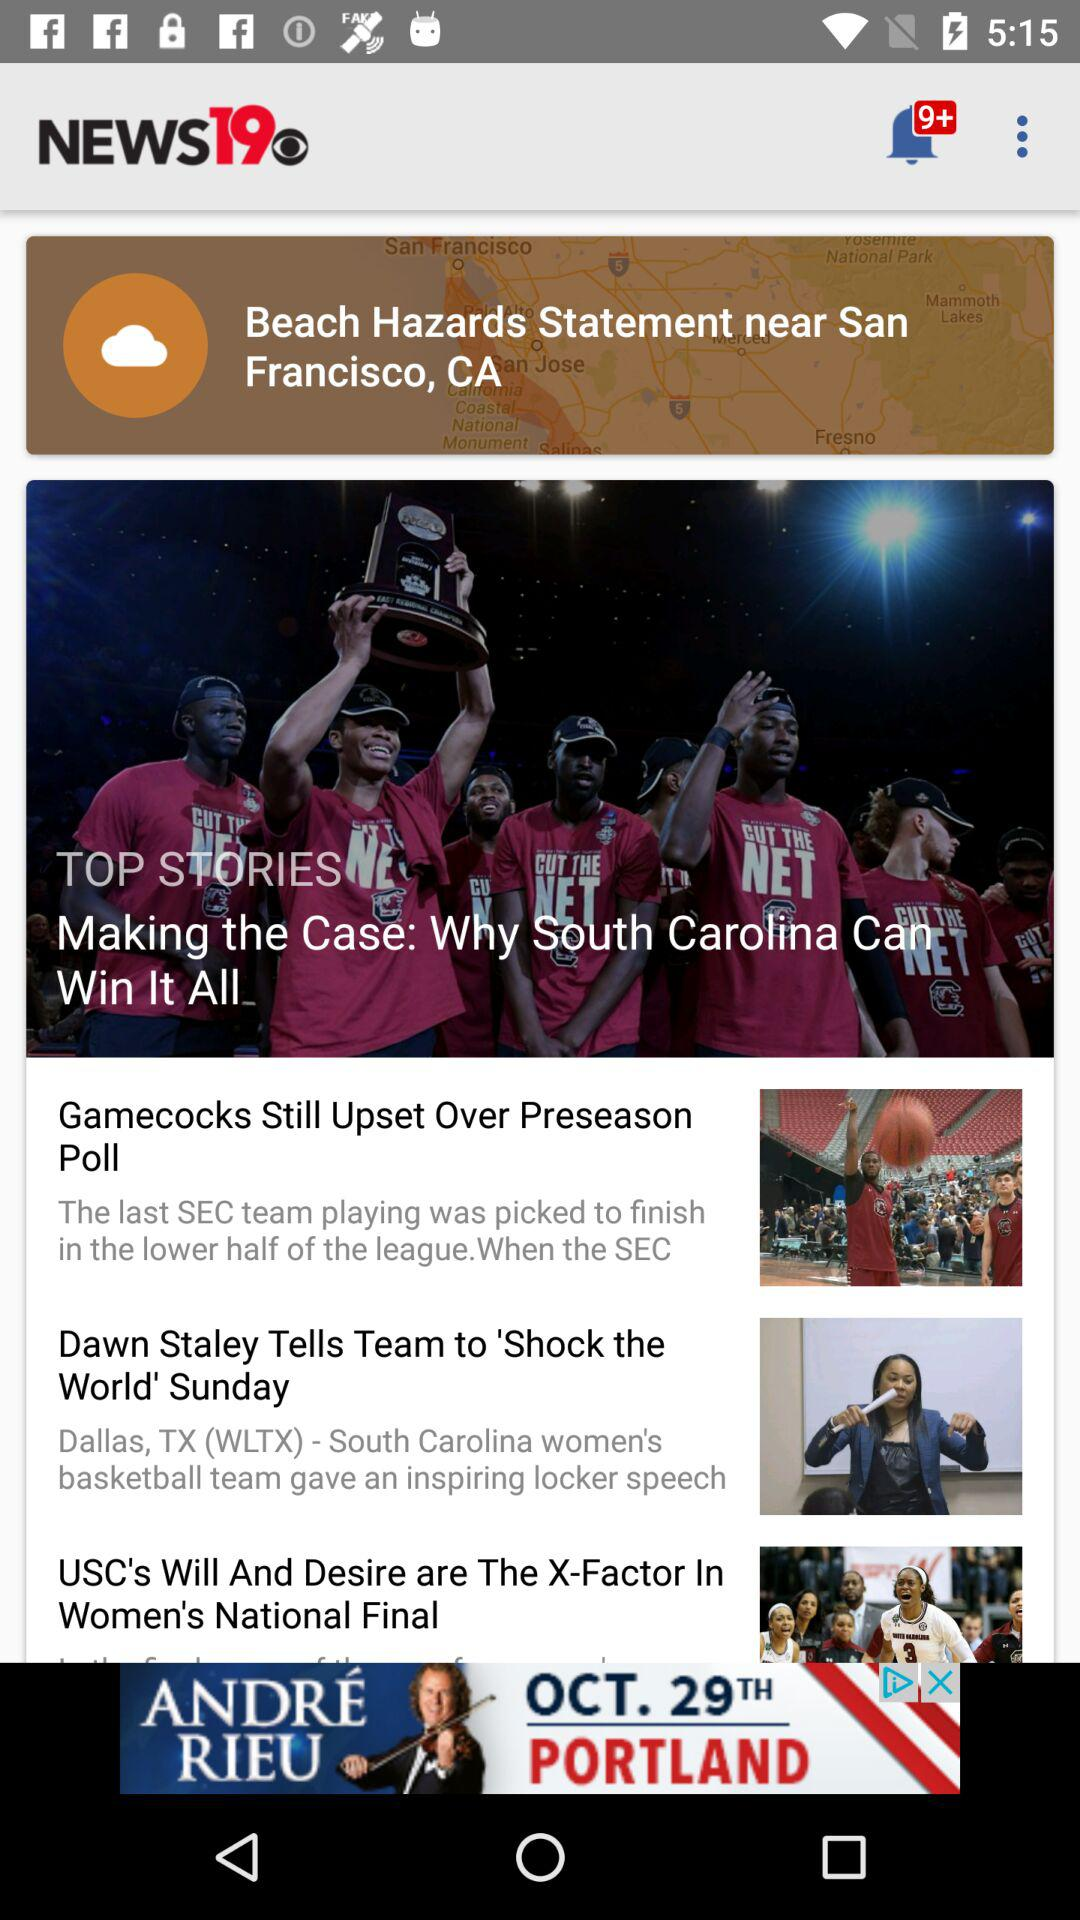Which city beaches received hazards statement? Hazards statement was received for beaches near San Francisco, CA. 